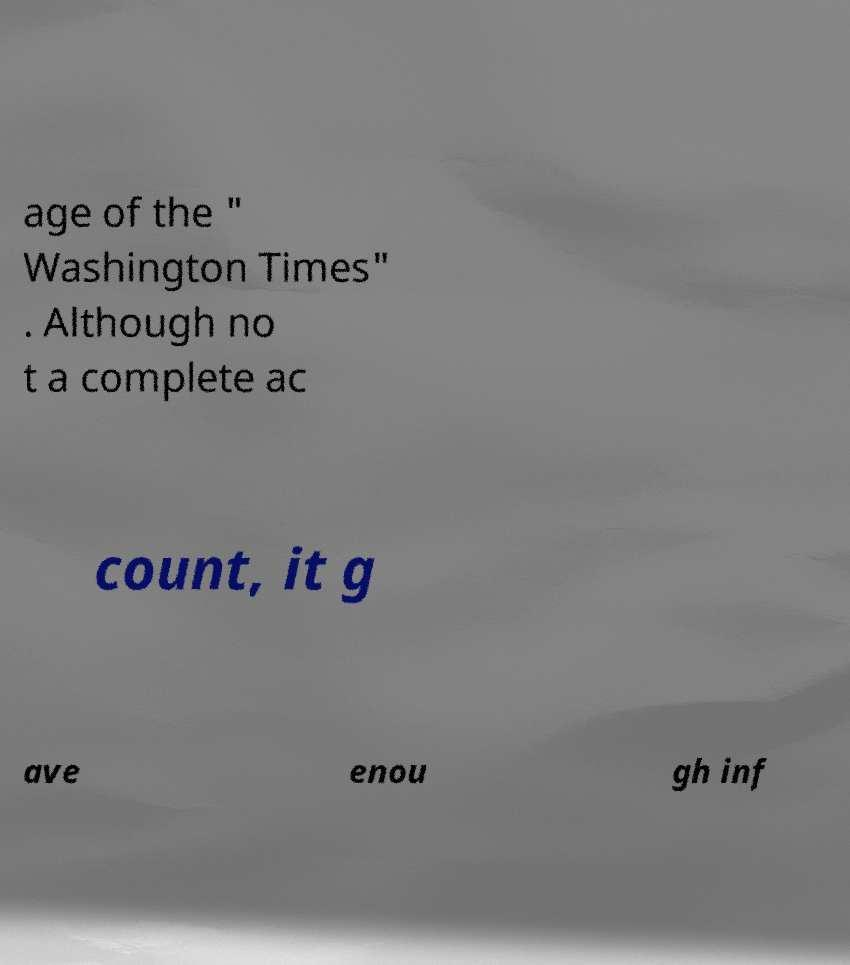Can you accurately transcribe the text from the provided image for me? age of the " Washington Times" . Although no t a complete ac count, it g ave enou gh inf 